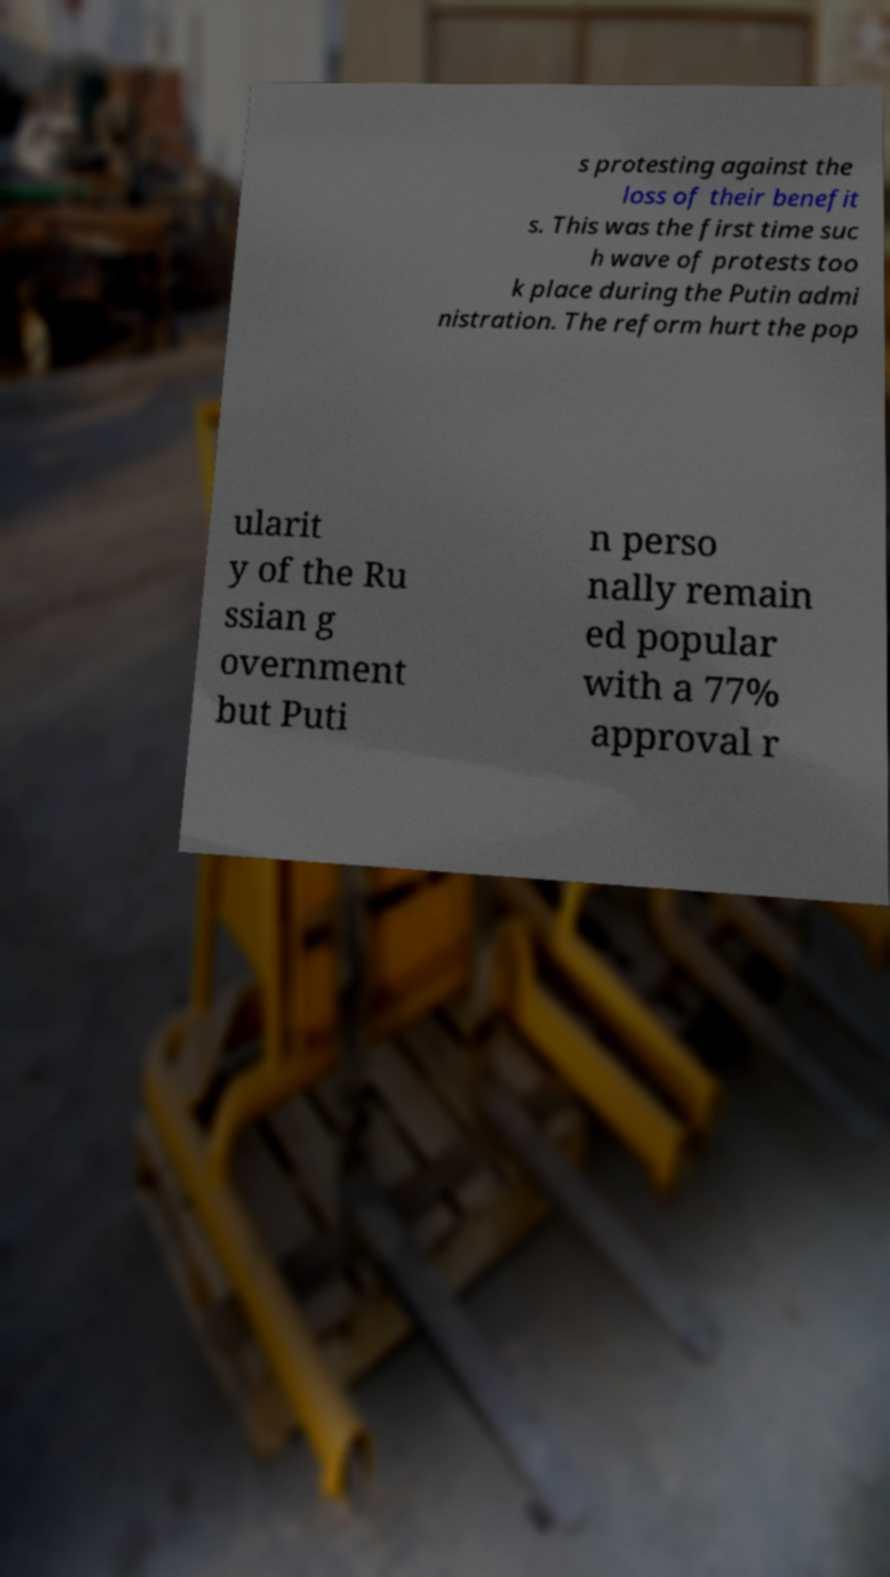For documentation purposes, I need the text within this image transcribed. Could you provide that? s protesting against the loss of their benefit s. This was the first time suc h wave of protests too k place during the Putin admi nistration. The reform hurt the pop ularit y of the Ru ssian g overnment but Puti n perso nally remain ed popular with a 77% approval r 